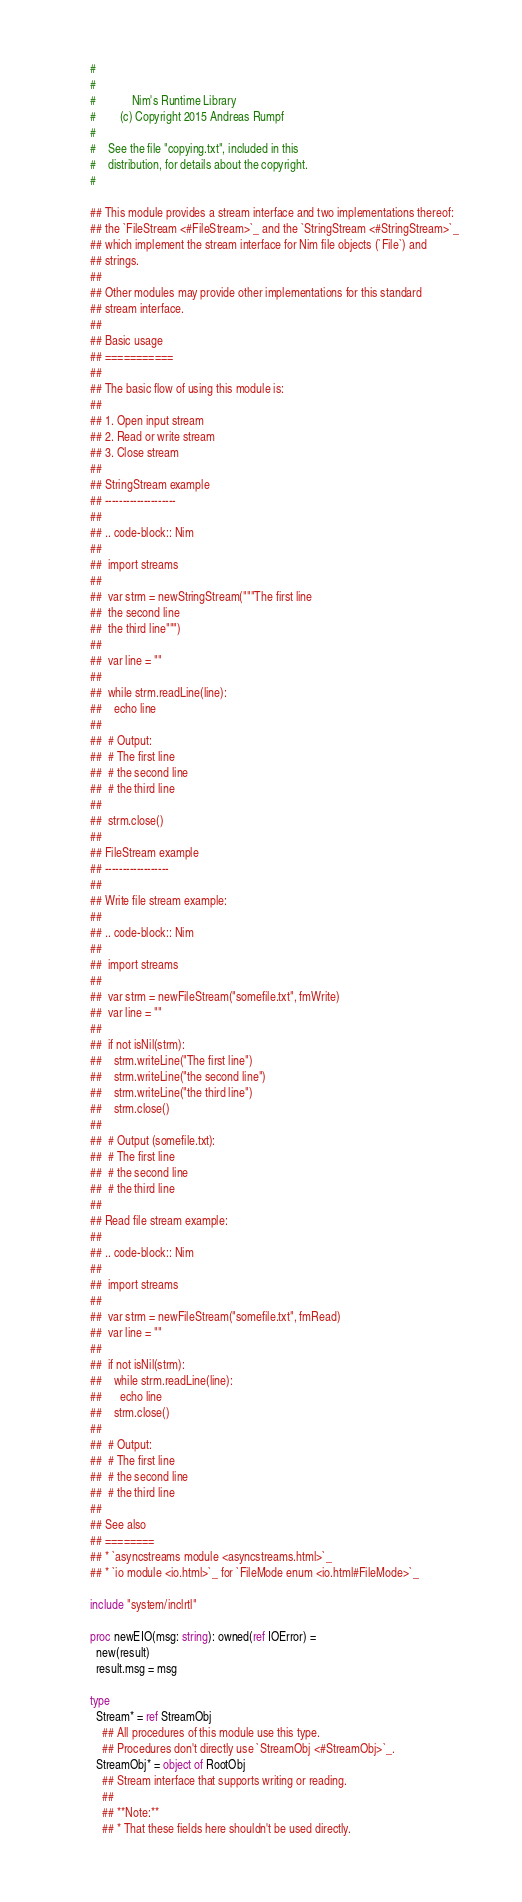Convert code to text. <code><loc_0><loc_0><loc_500><loc_500><_Nim_>#
#
#            Nim's Runtime Library
#        (c) Copyright 2015 Andreas Rumpf
#
#    See the file "copying.txt", included in this
#    distribution, for details about the copyright.
#

## This module provides a stream interface and two implementations thereof:
## the `FileStream <#FileStream>`_ and the `StringStream <#StringStream>`_
## which implement the stream interface for Nim file objects (`File`) and
## strings.
##
## Other modules may provide other implementations for this standard
## stream interface.
##
## Basic usage
## ===========
##
## The basic flow of using this module is:
##
## 1. Open input stream
## 2. Read or write stream
## 3. Close stream
##
## StringStream example
## --------------------
##
## .. code-block:: Nim
##
##  import streams
##
##  var strm = newStringStream("""The first line
##  the second line
##  the third line""")
##
##  var line = ""
##
##  while strm.readLine(line):
##    echo line
##
##  # Output:
##  # The first line
##  # the second line
##  # the third line
##
##  strm.close()
##
## FileStream example
## ------------------
##
## Write file stream example:
##
## .. code-block:: Nim
##
##  import streams
##
##  var strm = newFileStream("somefile.txt", fmWrite)
##  var line = ""
##
##  if not isNil(strm):
##    strm.writeLine("The first line")
##    strm.writeLine("the second line")
##    strm.writeLine("the third line")
##    strm.close()
##
##  # Output (somefile.txt):
##  # The first line
##  # the second line
##  # the third line
##
## Read file stream example:
##
## .. code-block:: Nim
##
##  import streams
##
##  var strm = newFileStream("somefile.txt", fmRead)
##  var line = ""
##
##  if not isNil(strm):
##    while strm.readLine(line):
##      echo line
##    strm.close()
##
##  # Output:
##  # The first line
##  # the second line
##  # the third line
##
## See also
## ========
## * `asyncstreams module <asyncstreams.html>`_
## * `io module <io.html>`_ for `FileMode enum <io.html#FileMode>`_

include "system/inclrtl"

proc newEIO(msg: string): owned(ref IOError) =
  new(result)
  result.msg = msg

type
  Stream* = ref StreamObj
    ## All procedures of this module use this type.
    ## Procedures don't directly use `StreamObj <#StreamObj>`_.
  StreamObj* = object of RootObj
    ## Stream interface that supports writing or reading.
    ##
    ## **Note:**
    ## * That these fields here shouldn't be used directly.</code> 